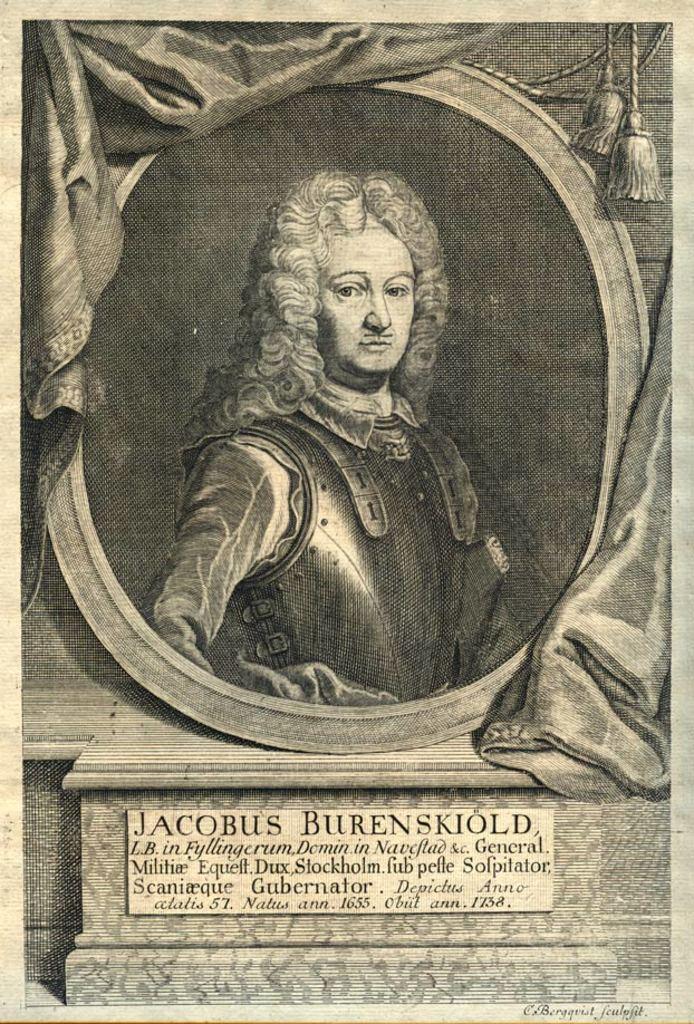Can you describe this image briefly? In this image there is a poster, on which we can see there is a black and white painting of person and under that there is a board with some note. 